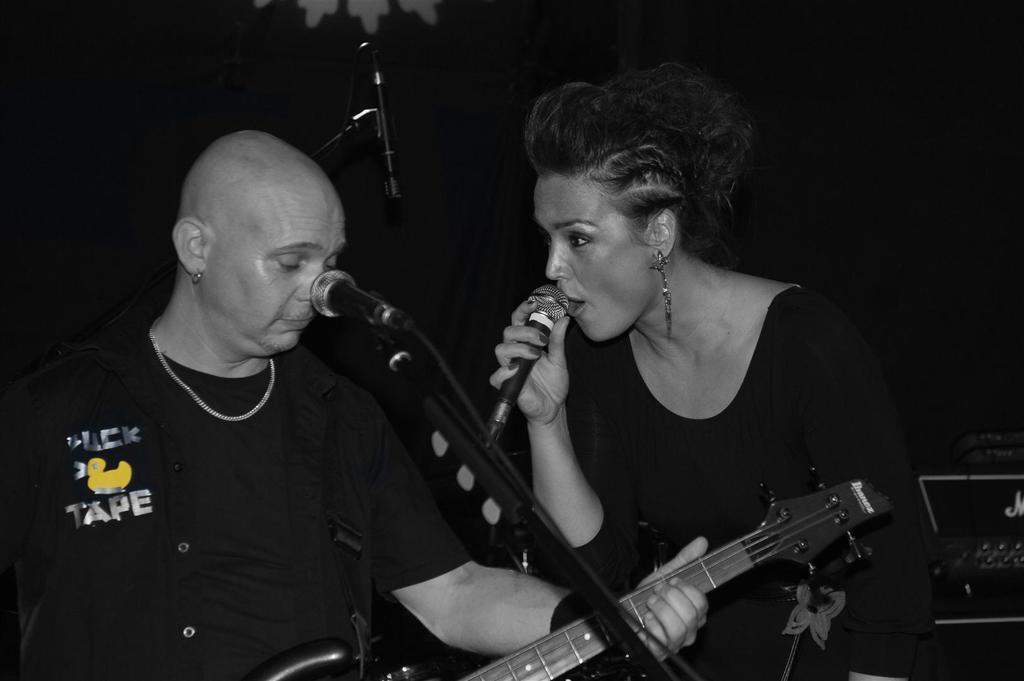How would you summarize this image in a sentence or two? In this picture there is a woman, holding a microphone and singing. On to her right there is a man playing a guitar. 